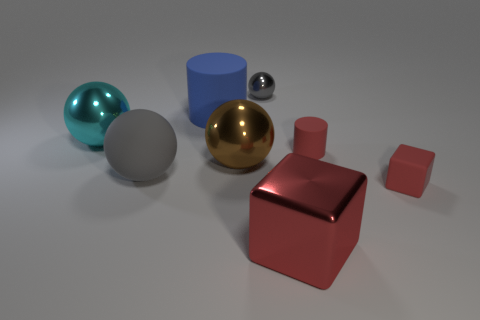Subtract all big brown balls. How many balls are left? 3 Subtract all gray balls. How many balls are left? 2 Subtract all cyan spheres. How many red cylinders are left? 1 Add 2 tiny blue metallic cylinders. How many tiny blue metallic cylinders exist? 2 Add 1 big red metallic cubes. How many objects exist? 9 Subtract 0 cyan blocks. How many objects are left? 8 Subtract all cylinders. How many objects are left? 6 Subtract 3 spheres. How many spheres are left? 1 Subtract all brown spheres. Subtract all red blocks. How many spheres are left? 3 Subtract all large brown shiny things. Subtract all blue cylinders. How many objects are left? 6 